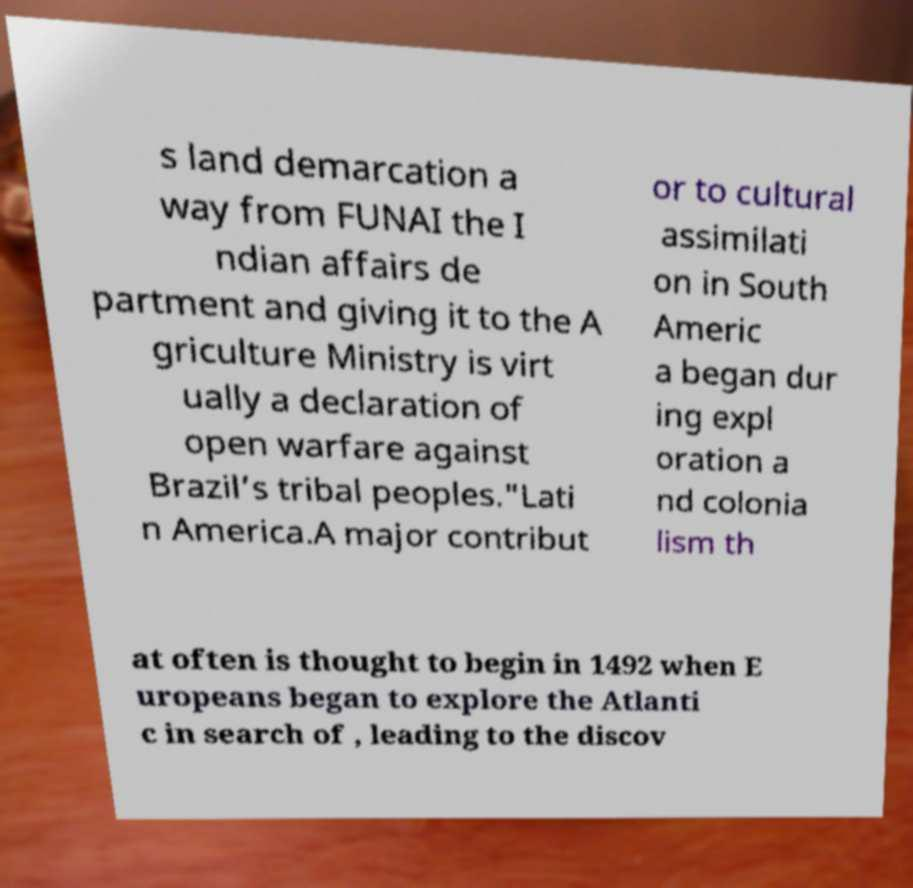Can you read and provide the text displayed in the image?This photo seems to have some interesting text. Can you extract and type it out for me? s land demarcation a way from FUNAI the I ndian affairs de partment and giving it to the A griculture Ministry is virt ually a declaration of open warfare against Brazil’s tribal peoples."Lati n America.A major contribut or to cultural assimilati on in South Americ a began dur ing expl oration a nd colonia lism th at often is thought to begin in 1492 when E uropeans began to explore the Atlanti c in search of , leading to the discov 